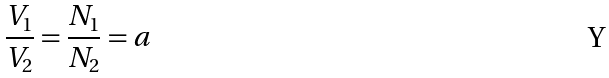<formula> <loc_0><loc_0><loc_500><loc_500>\frac { V _ { 1 } } { V _ { 2 } } = \frac { N _ { 1 } } { N _ { 2 } } = a</formula> 